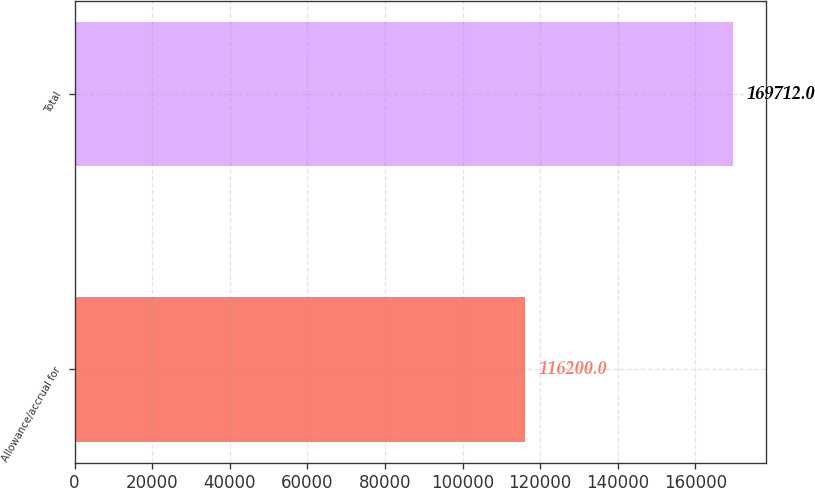<chart> <loc_0><loc_0><loc_500><loc_500><bar_chart><fcel>Allowance/accrual for<fcel>Total<nl><fcel>116200<fcel>169712<nl></chart> 